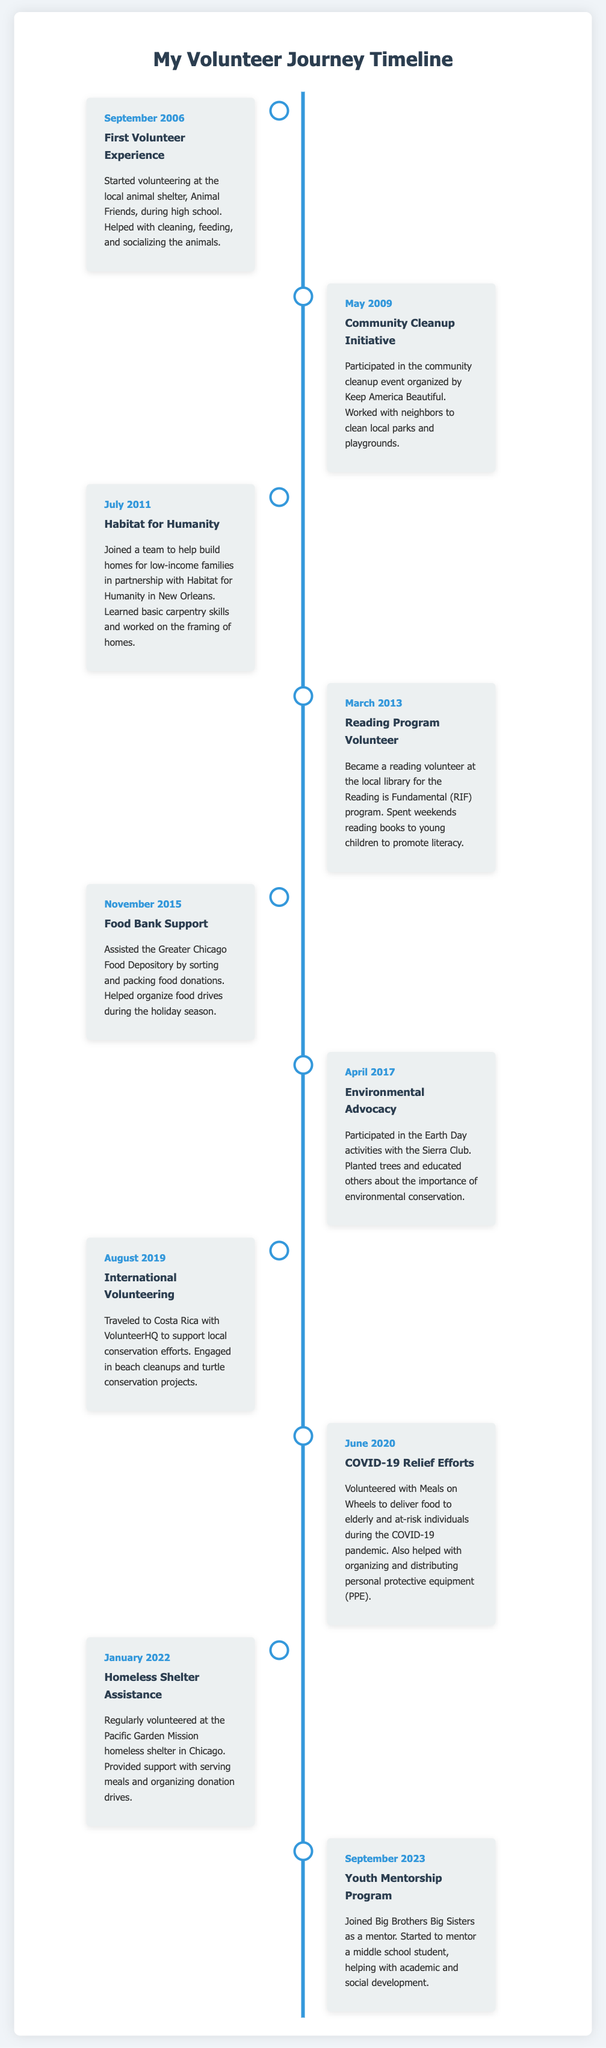what was the first volunteer experience? The document states the first volunteer experience was at Animal Friends, a local animal shelter, during high school.
Answer: Animal Friends when did the community cleanup initiative take place? According to the timeline, the community cleanup initiative occurred in May 2009.
Answer: May 2009 how many years passed between the first experience and Habitat for Humanity? The first experience was in September 2006 and Habitat for Humanity was in July 2011, which is nearly 5 years apart.
Answer: 5 years what organization was involved in the COVID-19 relief efforts? The document mentions Meals on Wheels in connection with the COVID-19 relief efforts.
Answer: Meals on Wheels which volunteering experience involved tree planting? The timeline highlights participation in Earth Day activities with the Sierra Club, which included planting trees.
Answer: Sierra Club how many distinct volunteer experiences are listed? Counting all experiences from the timeline yields a total of 10 distinct volunteer experiences.
Answer: 10 what activity was performed during the international volunteering experience? In the international volunteering experience, beach cleanups and turtle conservation projects were conducted.
Answer: beach cleanups and turtle conservation projects who did the volunteer mentor program with? The document indicates that the mentor program was joined with Big Brothers Big Sisters.
Answer: Big Brothers Big Sisters what type of event did the reading program focus on? The reading program focused on reading books to young children to promote literacy.
Answer: literacy 